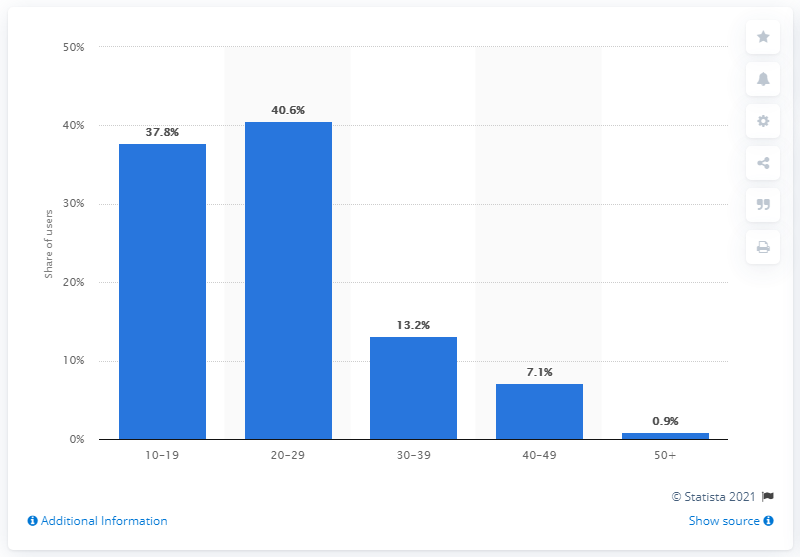Point out several critical features in this image. Twitch's user base was composed of 40.6% individuals between the ages of 20 and 29. 